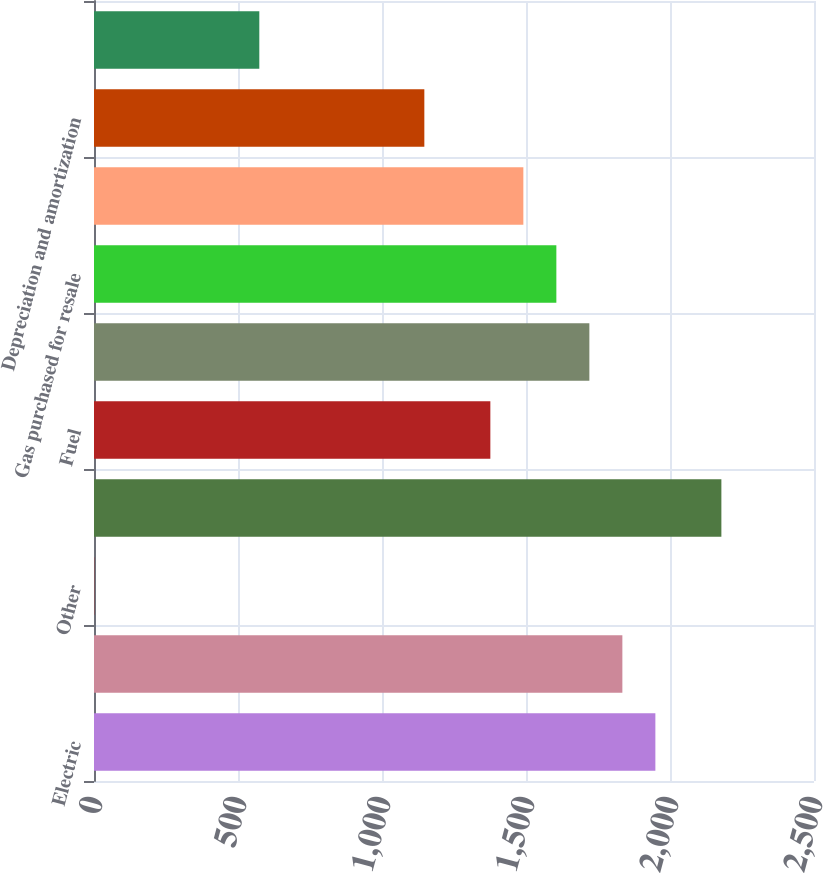Convert chart to OTSL. <chart><loc_0><loc_0><loc_500><loc_500><bar_chart><fcel>Electric<fcel>Gas<fcel>Other<fcel>Total operating revenues<fcel>Fuel<fcel>Purchased power<fcel>Gas purchased for resale<fcel>Other operations and<fcel>Depreciation and amortization<fcel>Taxes other than income taxes<nl><fcel>1949.2<fcel>1834.6<fcel>1<fcel>2178.4<fcel>1376.2<fcel>1720<fcel>1605.4<fcel>1490.8<fcel>1147<fcel>574<nl></chart> 